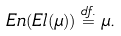<formula> <loc_0><loc_0><loc_500><loc_500>E n ( E l ( \mu ) ) \stackrel { d f . } { = } \mu .</formula> 